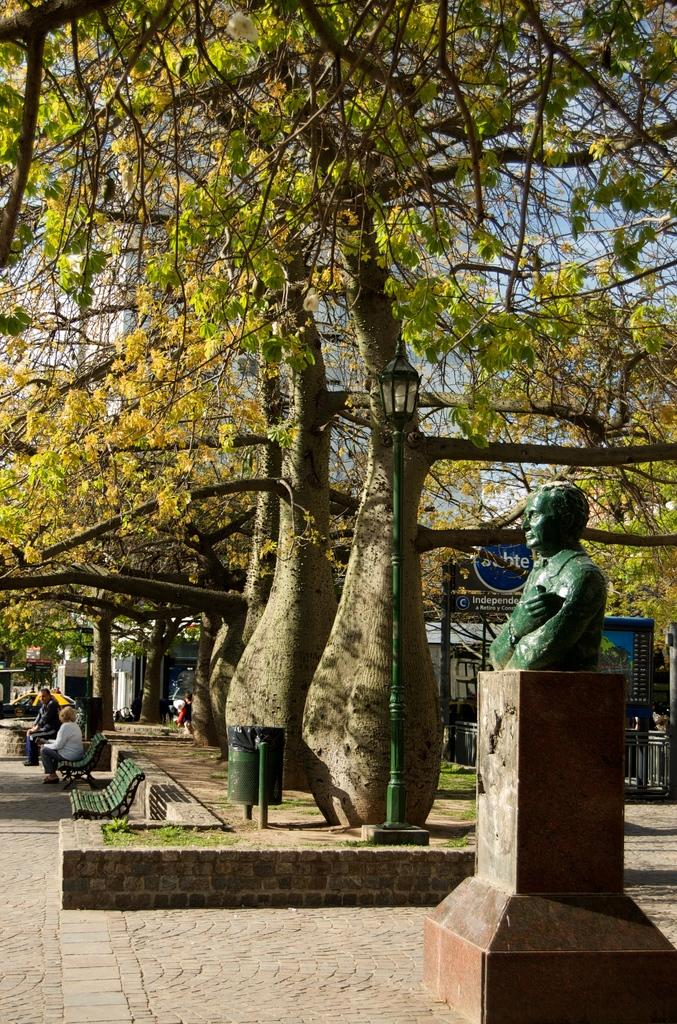What is the main subject of the sculpture in the image? There is a sculpture of a person in the image. What are the people in the image doing? There are groups of persons sitting on benches in the image. What objects can be seen in the image that are used for displaying information or advertisements? There are boards in the image. What objects can be seen in the image that are used for supporting structures or signs? There are poles in the image. What is the source of illumination in the image? There is light in the image. What type of structures can be seen in the image? There are buildings in the image. What type of vegetation can be seen in the image? There are trees in the image. What object can be seen in the image for disposing of waste? There is a dustbin in the image. What type of ground cover can be seen in the image? There is grass in the image. How many bags of rice can be seen in the image? There is no rice present in the image. What type of impulse can be seen affecting the behavior of the people in the image? There is no indication of any impulse affecting the behavior of the people in the image. 